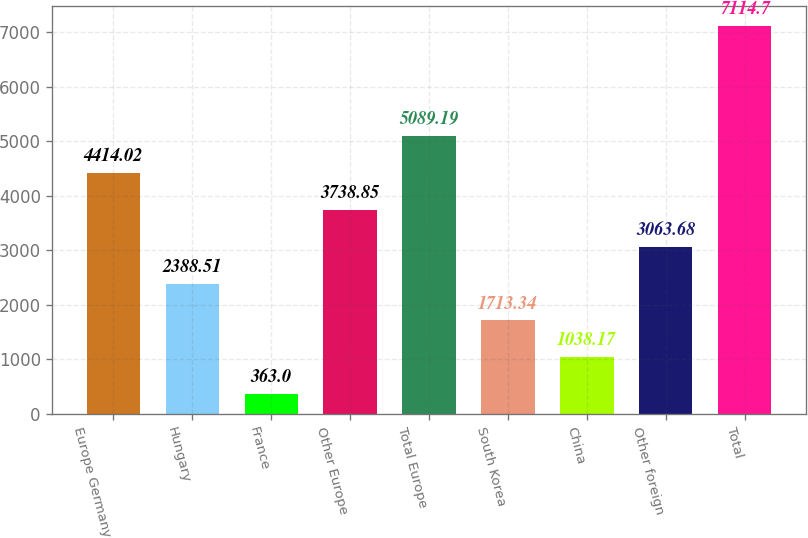Convert chart to OTSL. <chart><loc_0><loc_0><loc_500><loc_500><bar_chart><fcel>Europe Germany<fcel>Hungary<fcel>France<fcel>Other Europe<fcel>Total Europe<fcel>South Korea<fcel>China<fcel>Other foreign<fcel>Total<nl><fcel>4414.02<fcel>2388.51<fcel>363<fcel>3738.85<fcel>5089.19<fcel>1713.34<fcel>1038.17<fcel>3063.68<fcel>7114.7<nl></chart> 